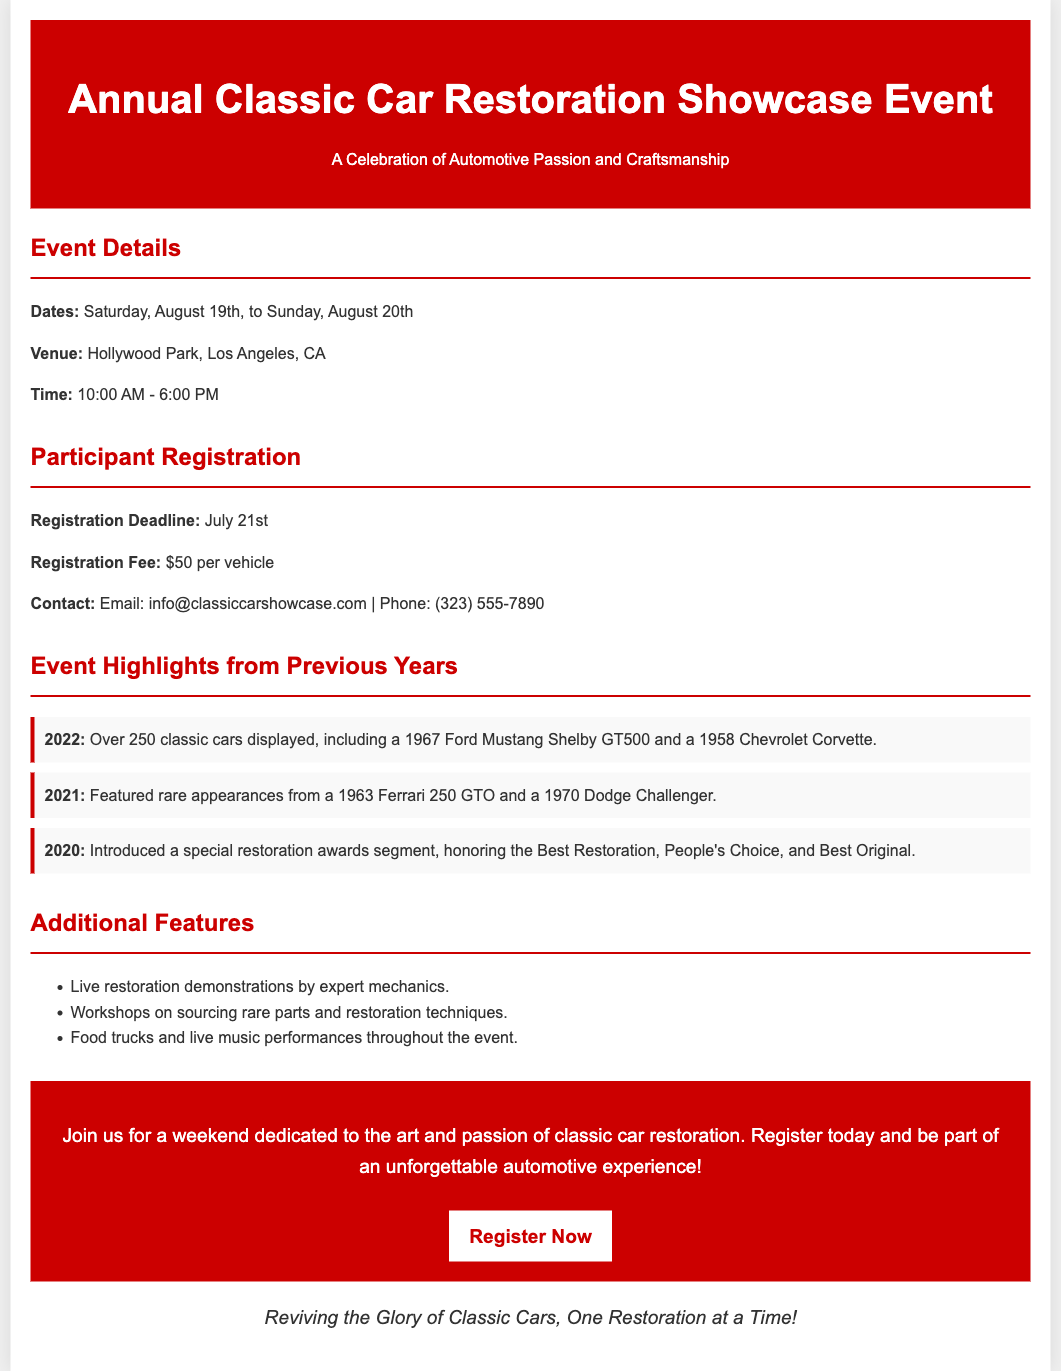What are the event dates? The event dates are explicitly mentioned in the document as August 19th and August 20th.
Answer: August 19th to August 20th Where is the event taking place? The venue for the event is specified as Hollywood Park, Los Angeles, CA.
Answer: Hollywood Park, Los Angeles, CA What is the registration fee per vehicle? The document clearly states that the registration fee is $50 per vehicle.
Answer: $50 When is the registration deadline? The registration deadline is mentioned as July 21st in the document.
Answer: July 21st What was a highlight from the 2022 event? The document lists that a 1967 Ford Mustang Shelby GT500 was displayed in 2022, highlighting a notable vehicle.
Answer: 1967 Ford Mustang Shelby GT500 What will participants learn in the workshops? The workshops will focus on sourcing rare parts and restoration techniques, providing specific educational content.
Answer: Sourcing rare parts and restoration techniques What is the purpose of the event? An overarching purpose of the event is provided in the title, emphasizing the celebration of automotive passion and craftsmanship.
Answer: Celebration of Automotive Passion and Craftsmanship What features are available during the event? The document mentions that live restoration demonstrations and food trucks will be available, indicating the event's activity offerings.
Answer: Live restoration demonstrations and food trucks How long does the event last each day? The time specified in the document shows that the event lasts from 10:00 AM to 6:00 PM each day.
Answer: 8 hours 